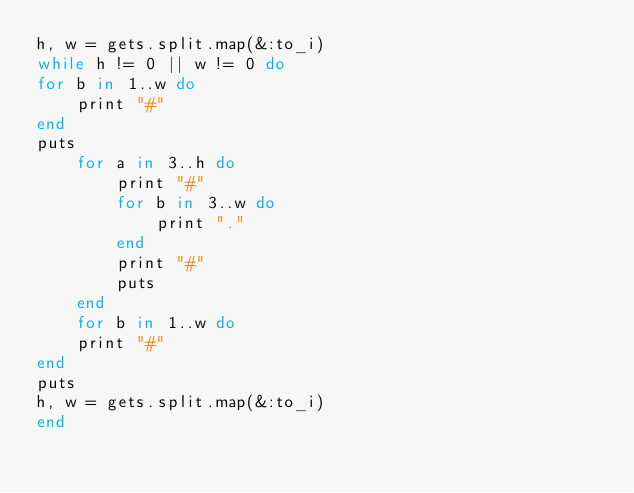Convert code to text. <code><loc_0><loc_0><loc_500><loc_500><_Ruby_>h, w = gets.split.map(&:to_i)
while h != 0 || w != 0 do
for b in 1..w do
	print "#"
end
puts
	for a in 3..h do
		print "#"
		for b in 3..w do
			print "."
		end
		print "#"
		puts
	end
	for b in 1..w do
	print "#"
end
puts
h, w = gets.split.map(&:to_i)
end</code> 